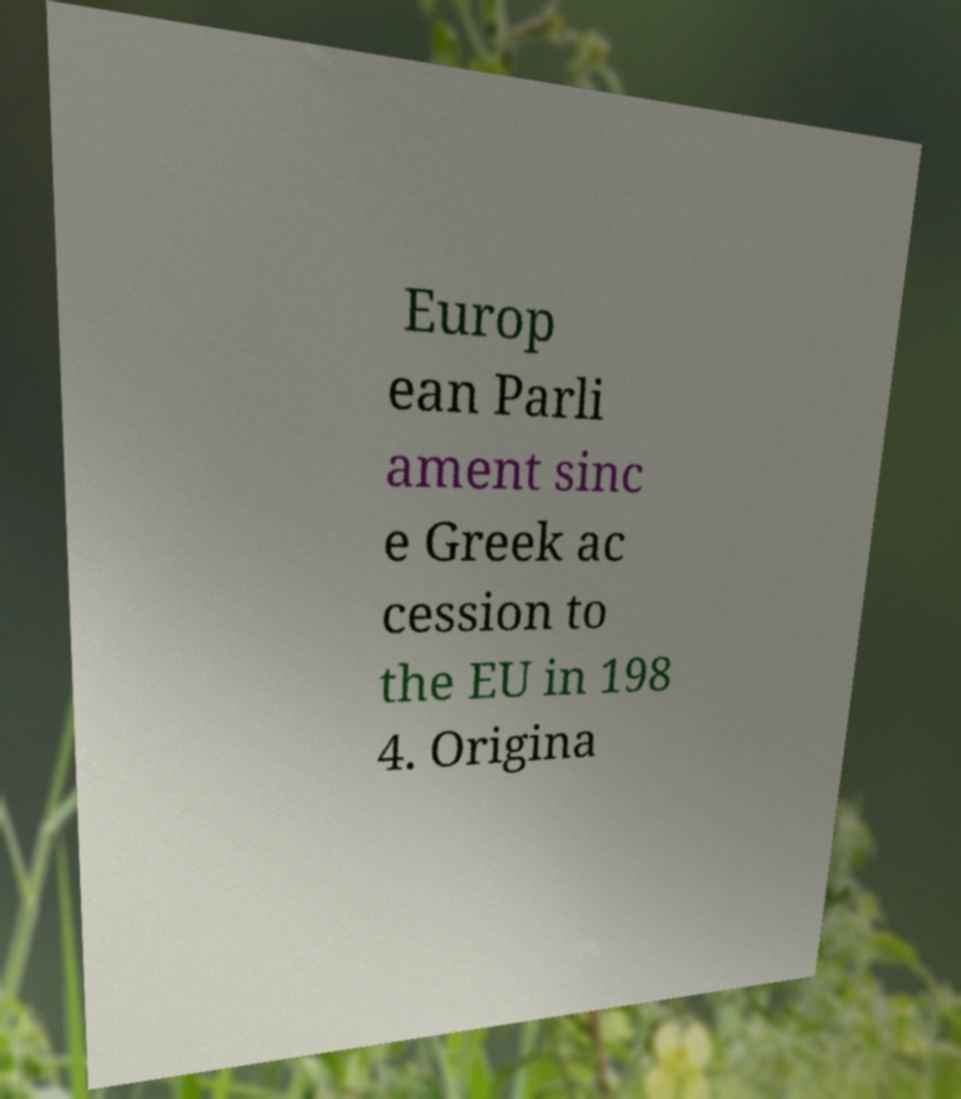Could you extract and type out the text from this image? Europ ean Parli ament sinc e Greek ac cession to the EU in 198 4. Origina 